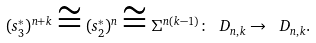Convert formula to latex. <formula><loc_0><loc_0><loc_500><loc_500>( s _ { 3 } ^ { * } ) ^ { n + k } \cong ( s _ { 2 } ^ { * } ) ^ { n } \cong \Sigma ^ { n ( k - 1 ) } \colon \ D _ { n , k } \to \ D _ { n , k } .</formula> 